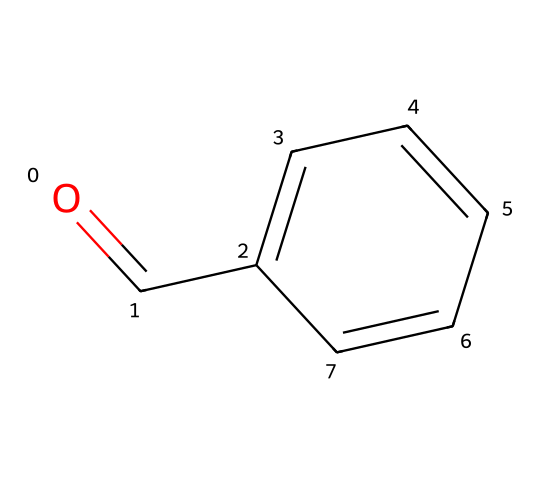What is the functional group present in this chemical? The chemical structure features a carbonyl group (C=O) at the end of the molecule, characteristic of aldehydes.
Answer: aldehyde How many carbon atoms are present in this molecule? The structure shows a six-membered aromatic ring (benzene) and one additional carbon from the carbonyl group, totaling seven carbon atoms.
Answer: seven What is the name of this chemical? The structure corresponds to benzaldehyde, identified by the aromatic ring and the aldehyde functional group attached to it.
Answer: benzaldehyde What type of reaction would benzaldehyde most likely participate in due to its functional group? The aldehyde group can undergo oxidation to form an acid, which is a typical reaction for aldehydes.
Answer: oxidation What is the molecular formula of benzaldehyde? By combining the elements present in the structure, it results in the formula C7H6O, with six hydrogen atoms, seven carbons, and one oxygen.
Answer: C7H6O What is the effect of the aromatic ring on the stability of the benzaldehyde molecule? The presence of the aromatic ring provides resonance stabilization, making the benzaldehyde more stable compared to aliphatic aldehydes.
Answer: resonance stabilization Is benzaldehyde a saturated or unsaturated compound? The presence of the double bond in the carbonyl group and the aromatic ring indicates that benzaldehyde is an unsaturated compound.
Answer: unsaturated 